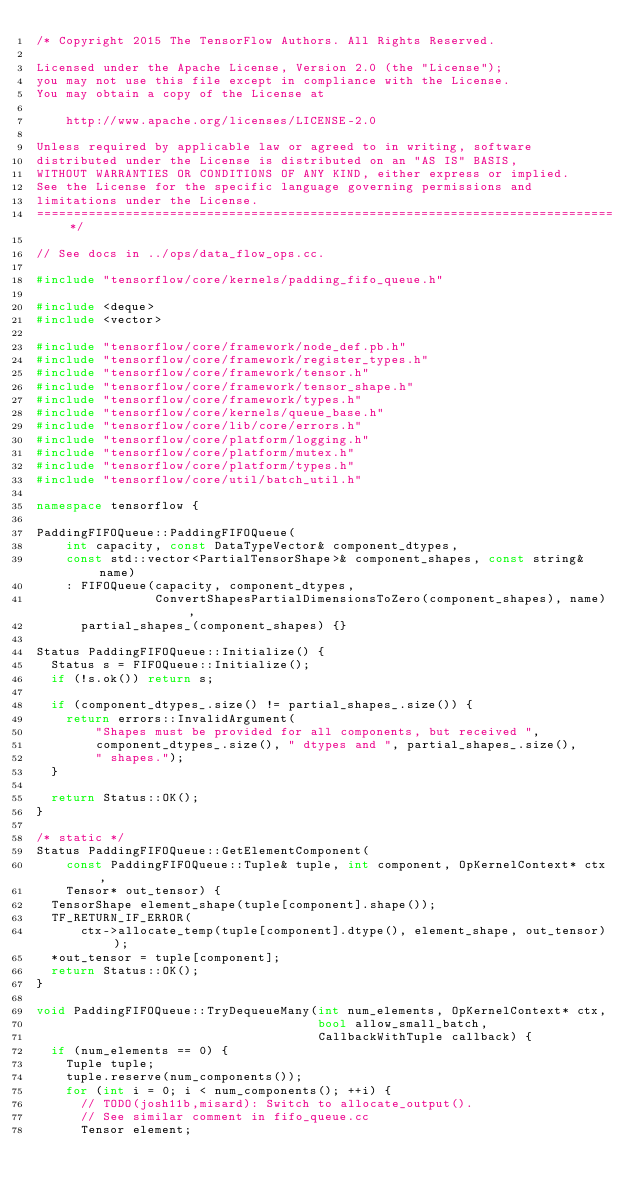Convert code to text. <code><loc_0><loc_0><loc_500><loc_500><_C++_>/* Copyright 2015 The TensorFlow Authors. All Rights Reserved.

Licensed under the Apache License, Version 2.0 (the "License");
you may not use this file except in compliance with the License.
You may obtain a copy of the License at

    http://www.apache.org/licenses/LICENSE-2.0

Unless required by applicable law or agreed to in writing, software
distributed under the License is distributed on an "AS IS" BASIS,
WITHOUT WARRANTIES OR CONDITIONS OF ANY KIND, either express or implied.
See the License for the specific language governing permissions and
limitations under the License.
==============================================================================*/

// See docs in ../ops/data_flow_ops.cc.

#include "tensorflow/core/kernels/padding_fifo_queue.h"

#include <deque>
#include <vector>

#include "tensorflow/core/framework/node_def.pb.h"
#include "tensorflow/core/framework/register_types.h"
#include "tensorflow/core/framework/tensor.h"
#include "tensorflow/core/framework/tensor_shape.h"
#include "tensorflow/core/framework/types.h"
#include "tensorflow/core/kernels/queue_base.h"
#include "tensorflow/core/lib/core/errors.h"
#include "tensorflow/core/platform/logging.h"
#include "tensorflow/core/platform/mutex.h"
#include "tensorflow/core/platform/types.h"
#include "tensorflow/core/util/batch_util.h"

namespace tensorflow {

PaddingFIFOQueue::PaddingFIFOQueue(
    int capacity, const DataTypeVector& component_dtypes,
    const std::vector<PartialTensorShape>& component_shapes, const string& name)
    : FIFOQueue(capacity, component_dtypes,
                ConvertShapesPartialDimensionsToZero(component_shapes), name),
      partial_shapes_(component_shapes) {}

Status PaddingFIFOQueue::Initialize() {
  Status s = FIFOQueue::Initialize();
  if (!s.ok()) return s;

  if (component_dtypes_.size() != partial_shapes_.size()) {
    return errors::InvalidArgument(
        "Shapes must be provided for all components, but received ",
        component_dtypes_.size(), " dtypes and ", partial_shapes_.size(),
        " shapes.");
  }

  return Status::OK();
}

/* static */
Status PaddingFIFOQueue::GetElementComponent(
    const PaddingFIFOQueue::Tuple& tuple, int component, OpKernelContext* ctx,
    Tensor* out_tensor) {
  TensorShape element_shape(tuple[component].shape());
  TF_RETURN_IF_ERROR(
      ctx->allocate_temp(tuple[component].dtype(), element_shape, out_tensor));
  *out_tensor = tuple[component];
  return Status::OK();
}

void PaddingFIFOQueue::TryDequeueMany(int num_elements, OpKernelContext* ctx,
                                      bool allow_small_batch,
                                      CallbackWithTuple callback) {
  if (num_elements == 0) {
    Tuple tuple;
    tuple.reserve(num_components());
    for (int i = 0; i < num_components(); ++i) {
      // TODO(josh11b,misard): Switch to allocate_output().
      // See similar comment in fifo_queue.cc
      Tensor element;</code> 